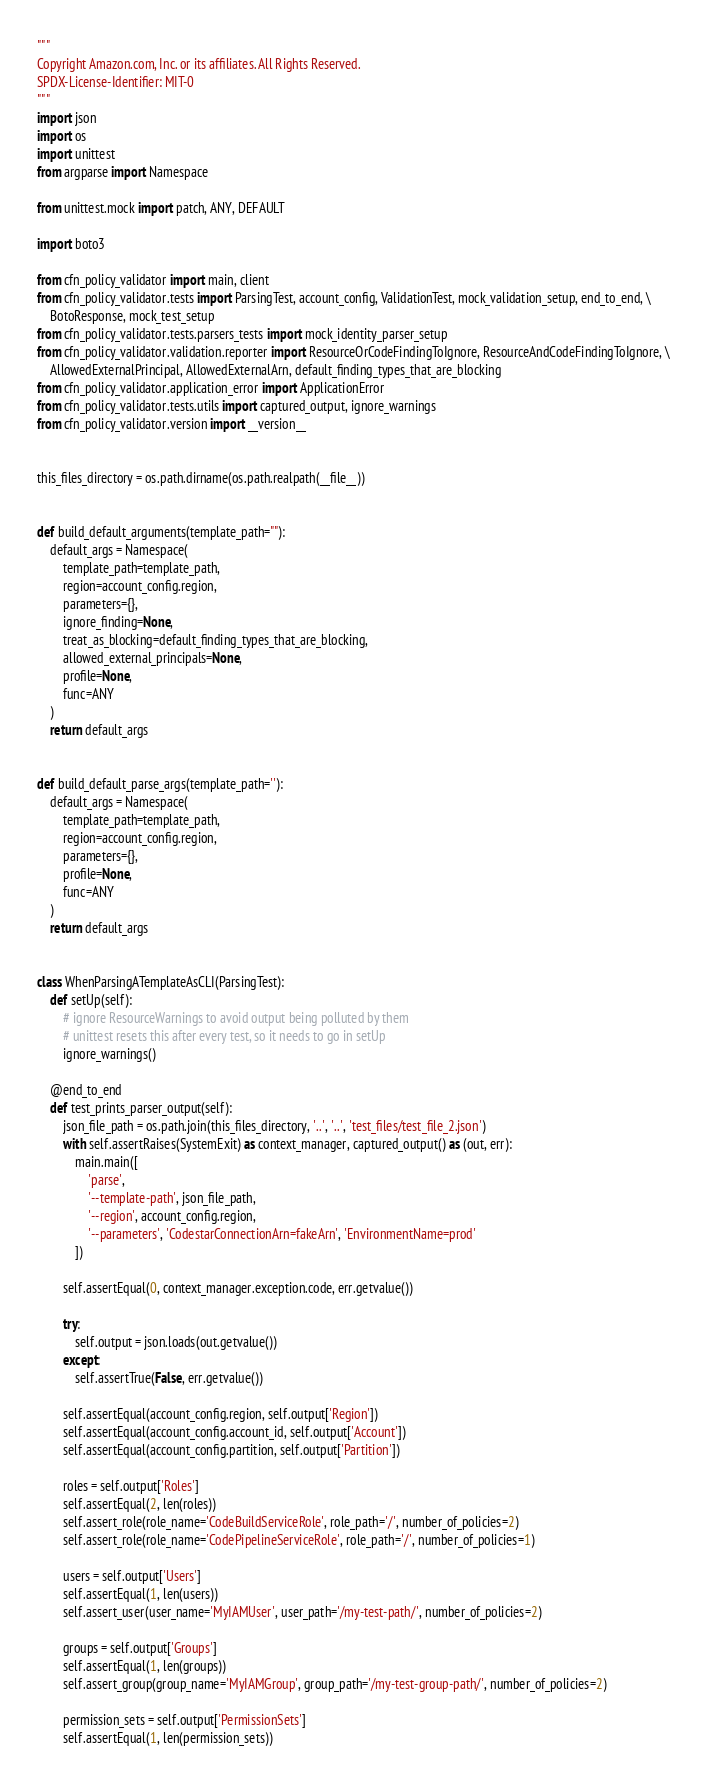<code> <loc_0><loc_0><loc_500><loc_500><_Python_>"""
Copyright Amazon.com, Inc. or its affiliates. All Rights Reserved.
SPDX-License-Identifier: MIT-0
"""
import json
import os
import unittest
from argparse import Namespace

from unittest.mock import patch, ANY, DEFAULT

import boto3

from cfn_policy_validator import main, client
from cfn_policy_validator.tests import ParsingTest, account_config, ValidationTest, mock_validation_setup, end_to_end, \
    BotoResponse, mock_test_setup
from cfn_policy_validator.tests.parsers_tests import mock_identity_parser_setup
from cfn_policy_validator.validation.reporter import ResourceOrCodeFindingToIgnore, ResourceAndCodeFindingToIgnore, \
    AllowedExternalPrincipal, AllowedExternalArn, default_finding_types_that_are_blocking
from cfn_policy_validator.application_error import ApplicationError
from cfn_policy_validator.tests.utils import captured_output, ignore_warnings
from cfn_policy_validator.version import __version__


this_files_directory = os.path.dirname(os.path.realpath(__file__))


def build_default_arguments(template_path=""):
    default_args = Namespace(
        template_path=template_path,
        region=account_config.region,
        parameters={},
        ignore_finding=None,
        treat_as_blocking=default_finding_types_that_are_blocking,
        allowed_external_principals=None,
        profile=None,
        func=ANY
    )
    return default_args


def build_default_parse_args(template_path=''):
    default_args = Namespace(
        template_path=template_path,
        region=account_config.region,
        parameters={},
        profile=None,
        func=ANY
    )
    return default_args


class WhenParsingATemplateAsCLI(ParsingTest):
    def setUp(self):
        # ignore ResourceWarnings to avoid output being polluted by them
        # unittest resets this after every test, so it needs to go in setUp
        ignore_warnings()

    @end_to_end
    def test_prints_parser_output(self):
        json_file_path = os.path.join(this_files_directory, '..', '..', 'test_files/test_file_2.json')
        with self.assertRaises(SystemExit) as context_manager, captured_output() as (out, err):
            main.main([
                'parse',
                '--template-path', json_file_path,
                '--region', account_config.region,
                '--parameters', 'CodestarConnectionArn=fakeArn', 'EnvironmentName=prod'
            ])

        self.assertEqual(0, context_manager.exception.code, err.getvalue())

        try:
            self.output = json.loads(out.getvalue())
        except:
            self.assertTrue(False, err.getvalue())

        self.assertEqual(account_config.region, self.output['Region'])
        self.assertEqual(account_config.account_id, self.output['Account'])
        self.assertEqual(account_config.partition, self.output['Partition'])

        roles = self.output['Roles']
        self.assertEqual(2, len(roles))
        self.assert_role(role_name='CodeBuildServiceRole', role_path='/', number_of_policies=2)
        self.assert_role(role_name='CodePipelineServiceRole', role_path='/', number_of_policies=1)

        users = self.output['Users']
        self.assertEqual(1, len(users))
        self.assert_user(user_name='MyIAMUser', user_path='/my-test-path/', number_of_policies=2)

        groups = self.output['Groups']
        self.assertEqual(1, len(groups))
        self.assert_group(group_name='MyIAMGroup', group_path='/my-test-group-path/', number_of_policies=2)

        permission_sets = self.output['PermissionSets']
        self.assertEqual(1, len(permission_sets))</code> 